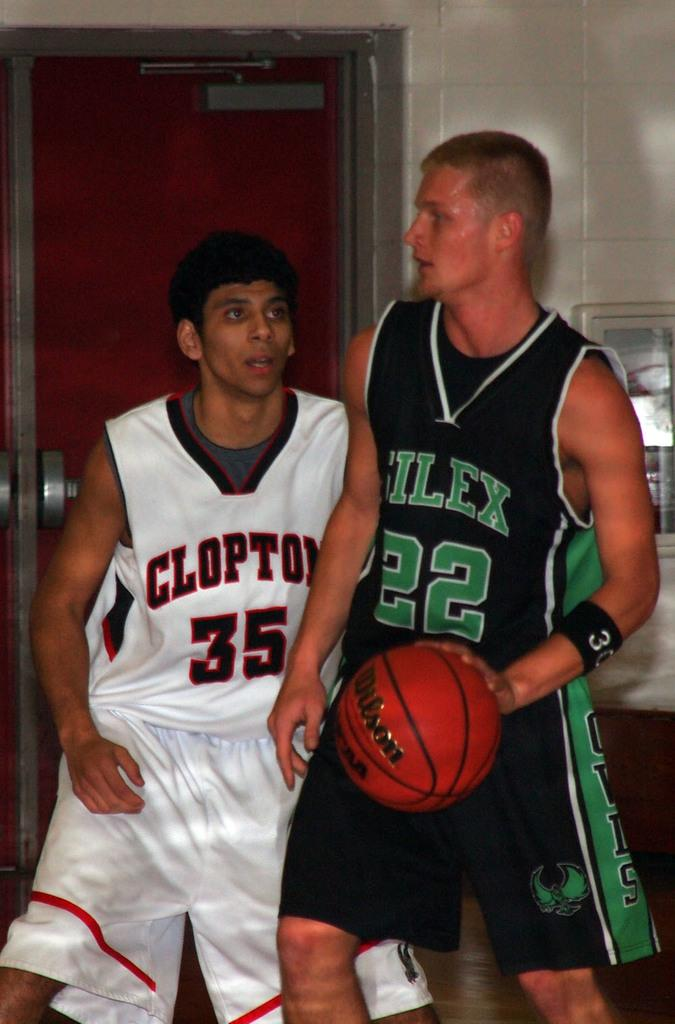<image>
Render a clear and concise summary of the photo. The man wearing number 22 currently has the basketball, and number 35 is nearby. 